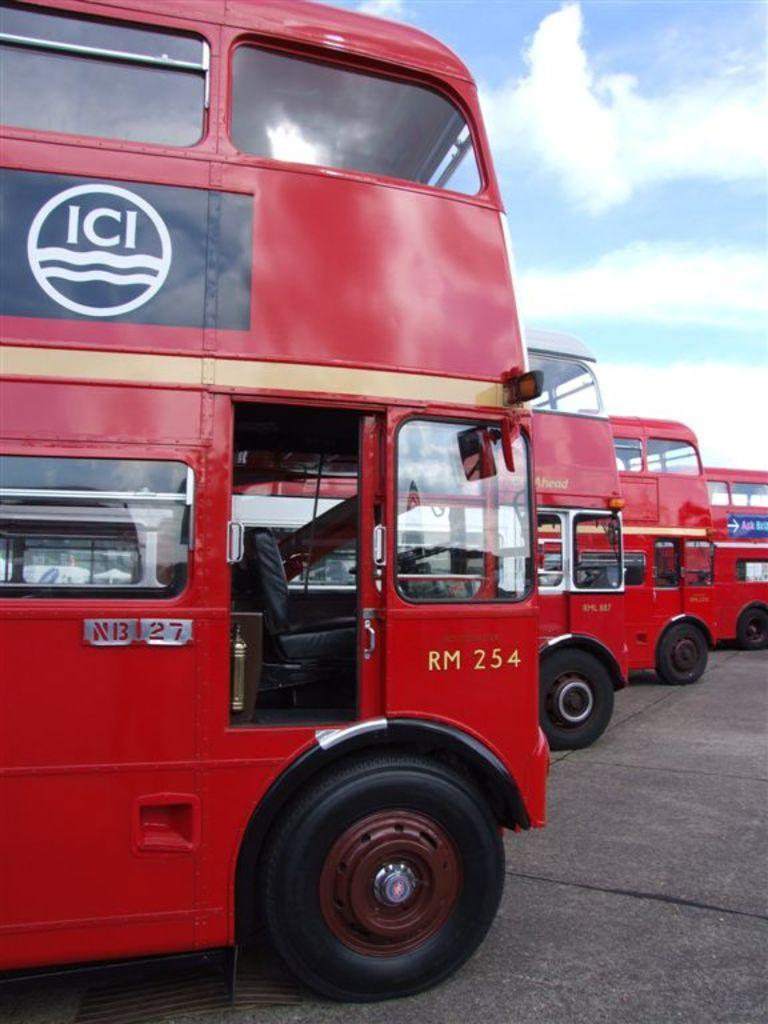What color are the buses in the image? The buses in the image are red-colored. What can be seen on the buses? There is writing on the buses. What is visible in the background of the image? There are clouds and the sky visible in the background of the image. What type of dinner is being served on the buses in the image? There is no dinner being served on the buses in the image; the focus is on the red-colored buses and the writing on them. 